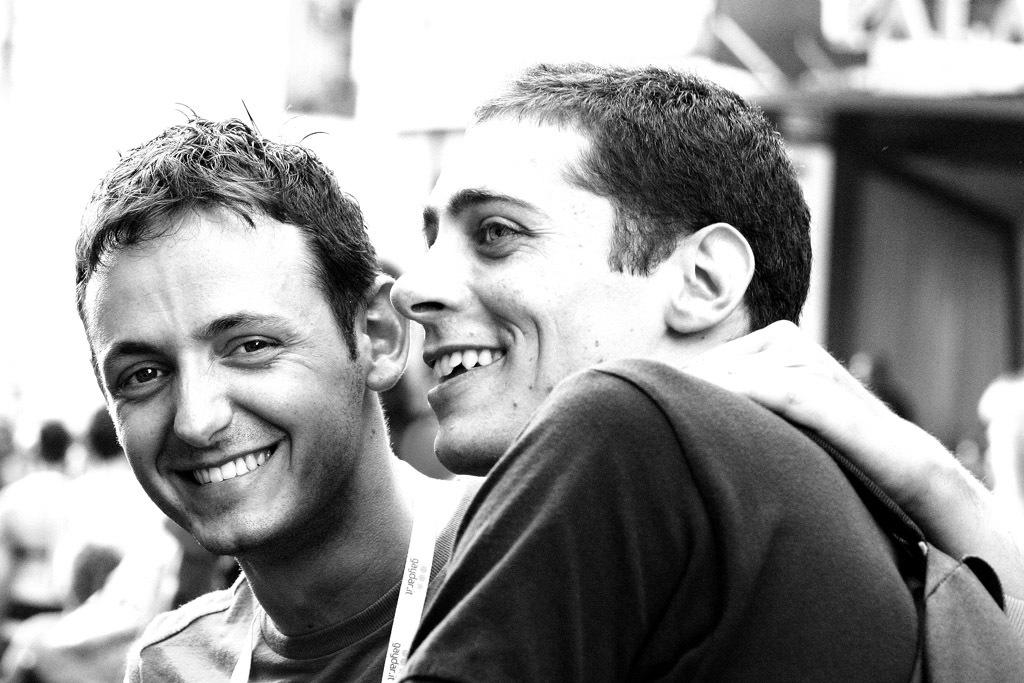What is the color scheme of the image? The image is black and white. How many people are in the image? There are two persons in the image. What is the facial expression of the persons in the image? The persons are smiling. Can you describe the background of the image? The background of the image is blurry. What type of prose is being recited by the person in the image? There is no indication in the image that anyone is reciting prose, as the focus is on the two persons smiling. 